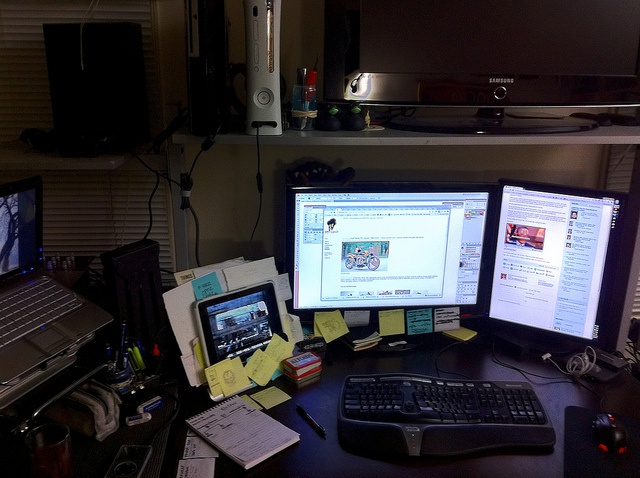Describe the objects in this image and their specific colors. I can see tv in black, gray, darkgray, and lightgray tones, tv in black and lightblue tones, tv in black and lavender tones, keyboard in black and gray tones, and laptop in black, gray, and navy tones in this image. 